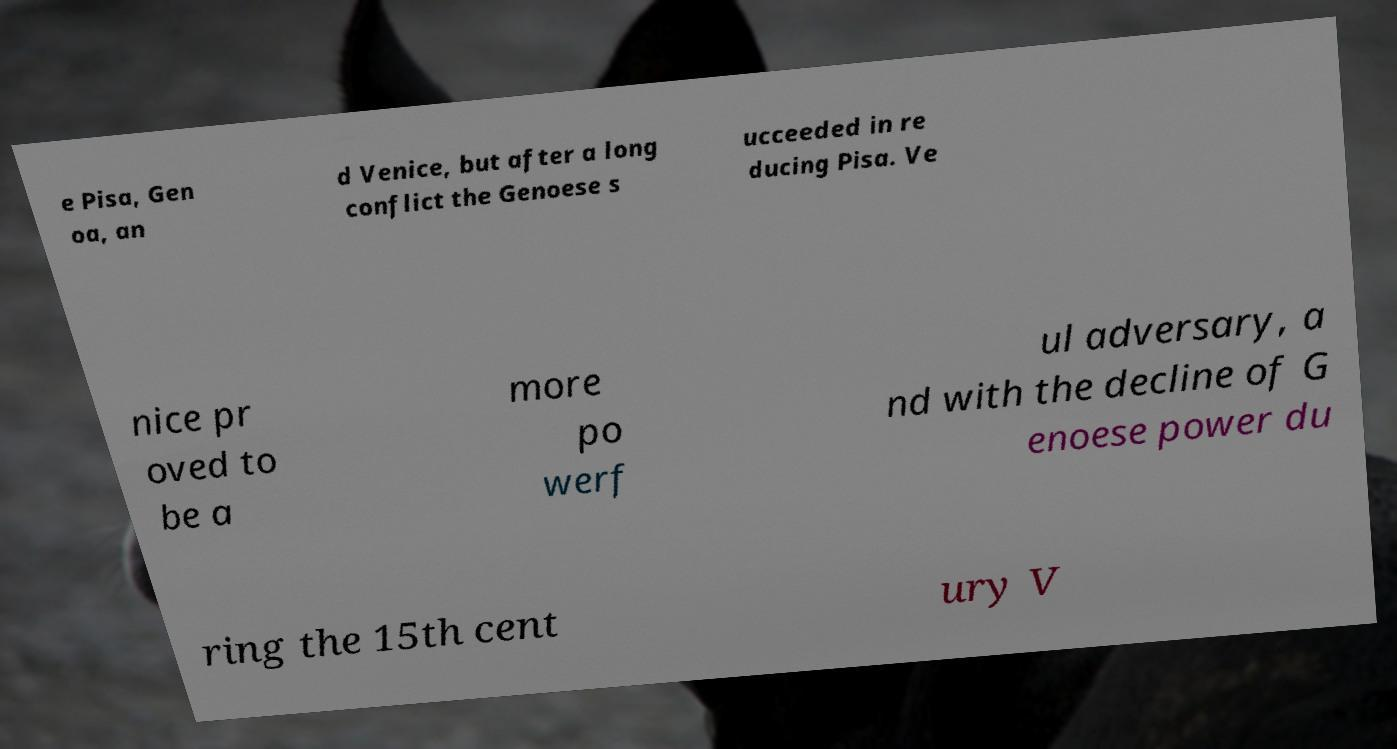Can you accurately transcribe the text from the provided image for me? e Pisa, Gen oa, an d Venice, but after a long conflict the Genoese s ucceeded in re ducing Pisa. Ve nice pr oved to be a more po werf ul adversary, a nd with the decline of G enoese power du ring the 15th cent ury V 